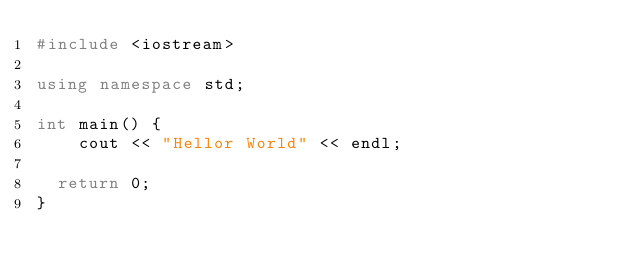Convert code to text. <code><loc_0><loc_0><loc_500><loc_500><_C++_>#include <iostream>

using namespace std;

int main() {
    cout << "Hellor World" << endl;

  return 0;
}
</code> 